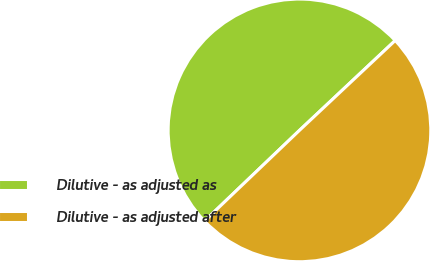Convert chart to OTSL. <chart><loc_0><loc_0><loc_500><loc_500><pie_chart><fcel>Dilutive - as adjusted as<fcel>Dilutive - as adjusted after<nl><fcel>50.14%<fcel>49.86%<nl></chart> 